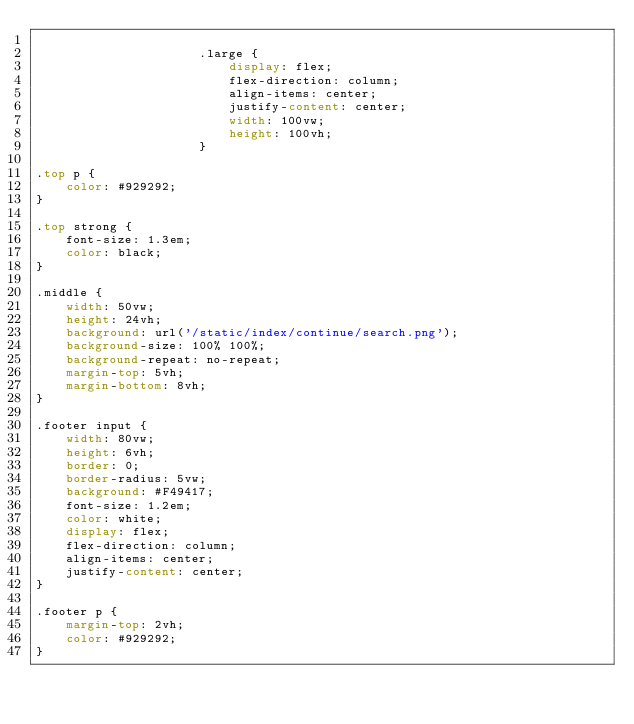Convert code to text. <code><loc_0><loc_0><loc_500><loc_500><_CSS_>
                      .large {
                          display: flex;
                          flex-direction: column;
                          align-items: center;
                          justify-content: center;
                          width: 100vw;
                          height: 100vh;
                      }

.top p {
    color: #929292;
}

.top strong {
    font-size: 1.3em;
    color: black;
}

.middle {
    width: 50vw;
    height: 24vh;
    background: url('/static/index/continue/search.png');
    background-size: 100% 100%;
    background-repeat: no-repeat;
    margin-top: 5vh;
    margin-bottom: 8vh;
}

.footer input {
    width: 80vw;
    height: 6vh;
    border: 0;
    border-radius: 5vw;
    background: #F49417;
    font-size: 1.2em;
    color: white;
    display: flex;
    flex-direction: column;
    align-items: center;
    justify-content: center;
}

.footer p {
    margin-top: 2vh;
    color: #929292;
}
</code> 